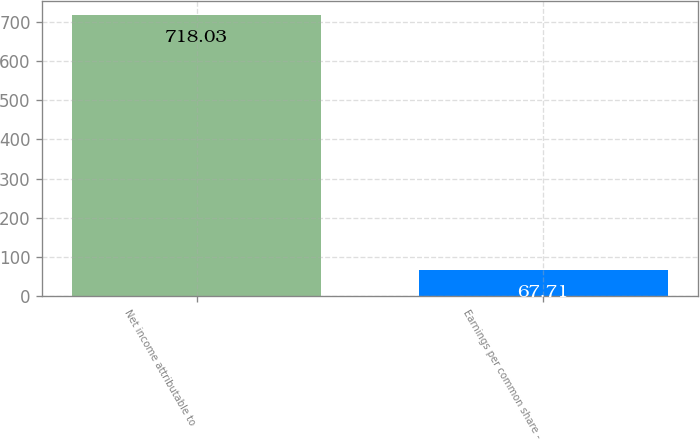<chart> <loc_0><loc_0><loc_500><loc_500><bar_chart><fcel>Net income attributable to<fcel>Earnings per common share -<nl><fcel>718.03<fcel>67.71<nl></chart> 